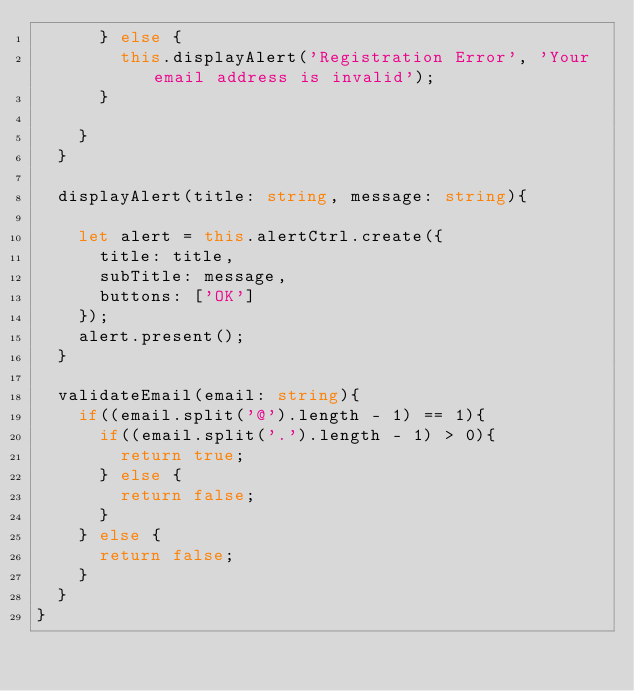<code> <loc_0><loc_0><loc_500><loc_500><_TypeScript_>      } else {
        this.displayAlert('Registration Error', 'Your email address is invalid');
      }
      
    }
  }

  displayAlert(title: string, message: string){

    let alert = this.alertCtrl.create({
      title: title,
      subTitle: message,
      buttons: ['OK']
    });
    alert.present();
  }

  validateEmail(email: string){
    if((email.split('@').length - 1) == 1){
      if((email.split('.').length - 1) > 0){
        return true;
      } else {
        return false;
      }
    } else {
      return false;
    }
  }
}
</code> 